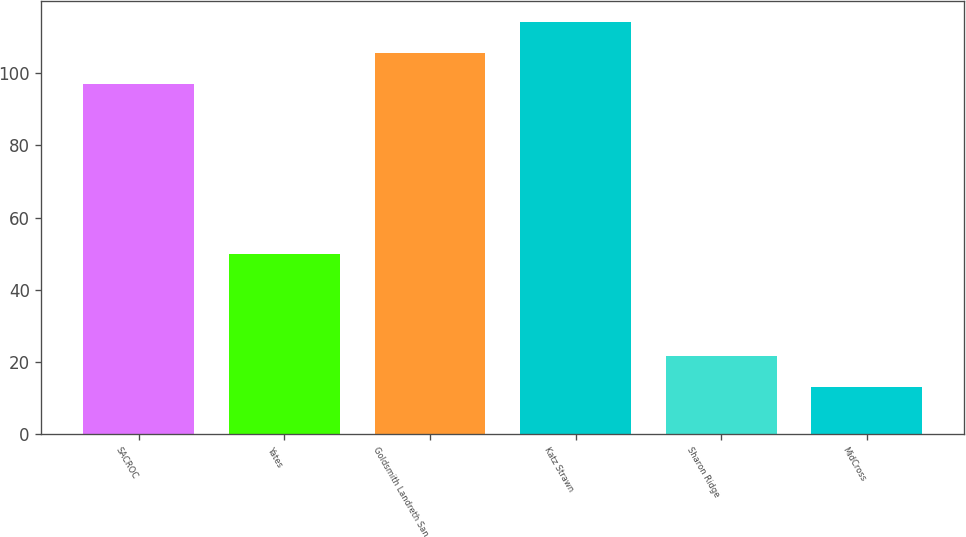Convert chart. <chart><loc_0><loc_0><loc_500><loc_500><bar_chart><fcel>SACROC<fcel>Yates<fcel>Goldsmith Landreth San<fcel>Katz Strawn<fcel>Sharon Ridge<fcel>MidCross<nl><fcel>97<fcel>50<fcel>105.6<fcel>114.2<fcel>21.6<fcel>13<nl></chart> 